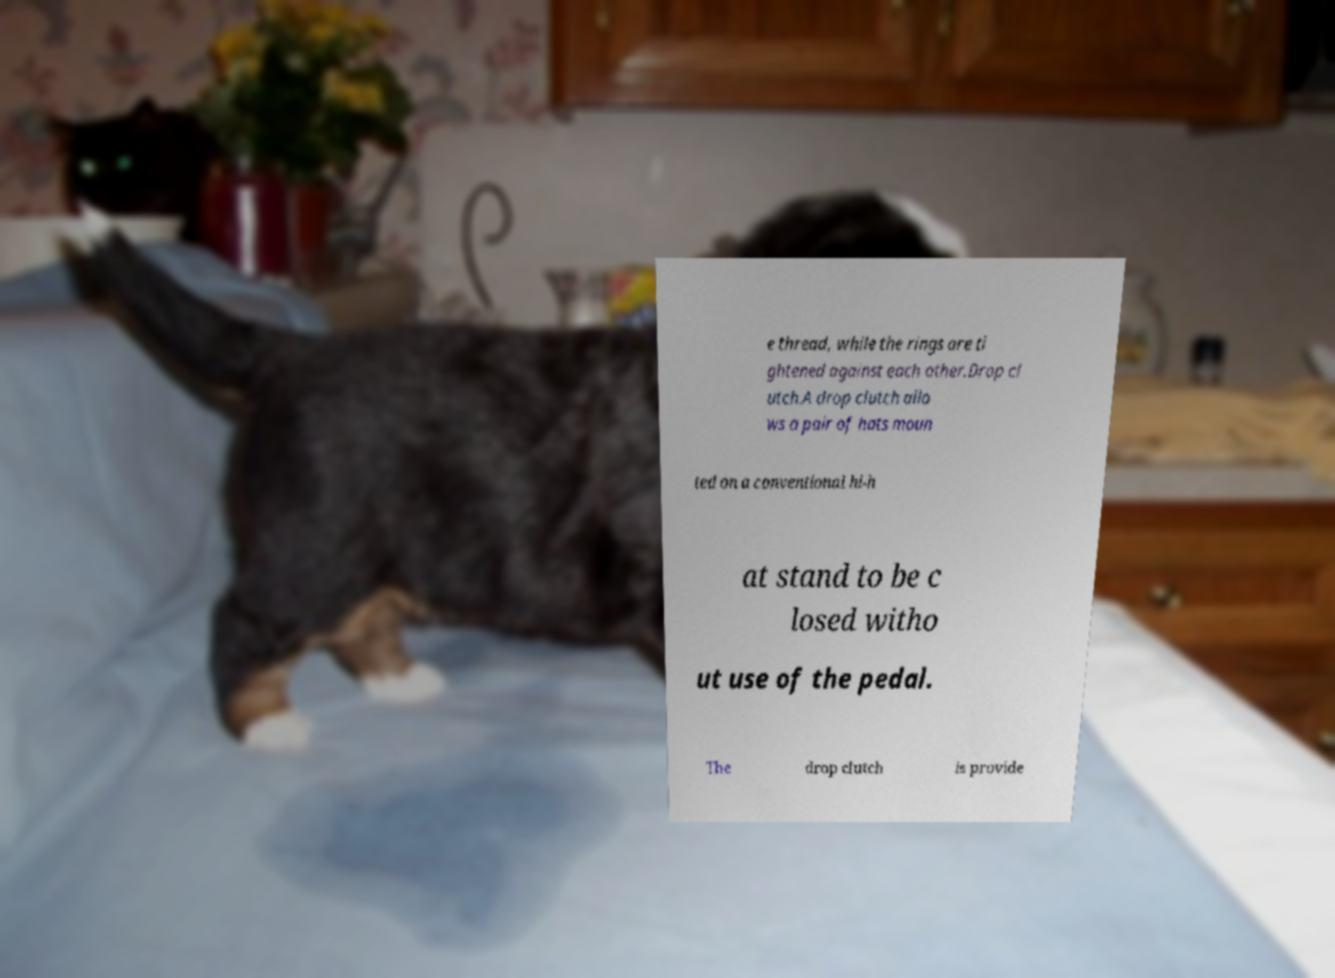For documentation purposes, I need the text within this image transcribed. Could you provide that? e thread, while the rings are ti ghtened against each other.Drop cl utch.A drop clutch allo ws a pair of hats moun ted on a conventional hi-h at stand to be c losed witho ut use of the pedal. The drop clutch is provide 